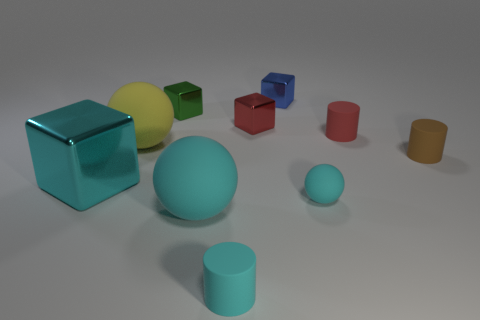Is the shape of the tiny red object that is right of the red block the same as  the brown thing?
Keep it short and to the point. Yes. What number of objects are either objects in front of the large yellow sphere or tiny green matte cubes?
Offer a terse response. 5. There is another large thing that is the same shape as the big cyan matte thing; what is its color?
Provide a succinct answer. Yellow. Are there any other things that are the same color as the big metal thing?
Provide a short and direct response. Yes. There is a cylinder that is behind the big yellow rubber object; how big is it?
Your response must be concise. Small. There is a large shiny object; does it have the same color as the small cylinder in front of the brown cylinder?
Your answer should be compact. Yes. How many other things are there of the same material as the large yellow ball?
Keep it short and to the point. 5. Is the number of cyan metallic objects greater than the number of cyan shiny cylinders?
Make the answer very short. Yes. Does the large matte ball in front of the small brown cylinder have the same color as the tiny matte ball?
Your answer should be very brief. Yes. What color is the big block?
Your answer should be very brief. Cyan. 